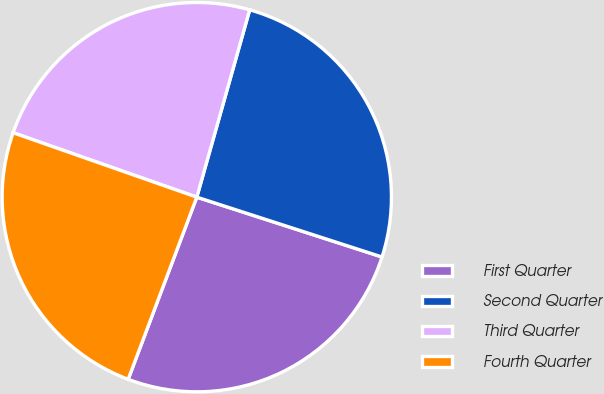Convert chart to OTSL. <chart><loc_0><loc_0><loc_500><loc_500><pie_chart><fcel>First Quarter<fcel>Second Quarter<fcel>Third Quarter<fcel>Fourth Quarter<nl><fcel>25.76%<fcel>25.59%<fcel>24.01%<fcel>24.63%<nl></chart> 